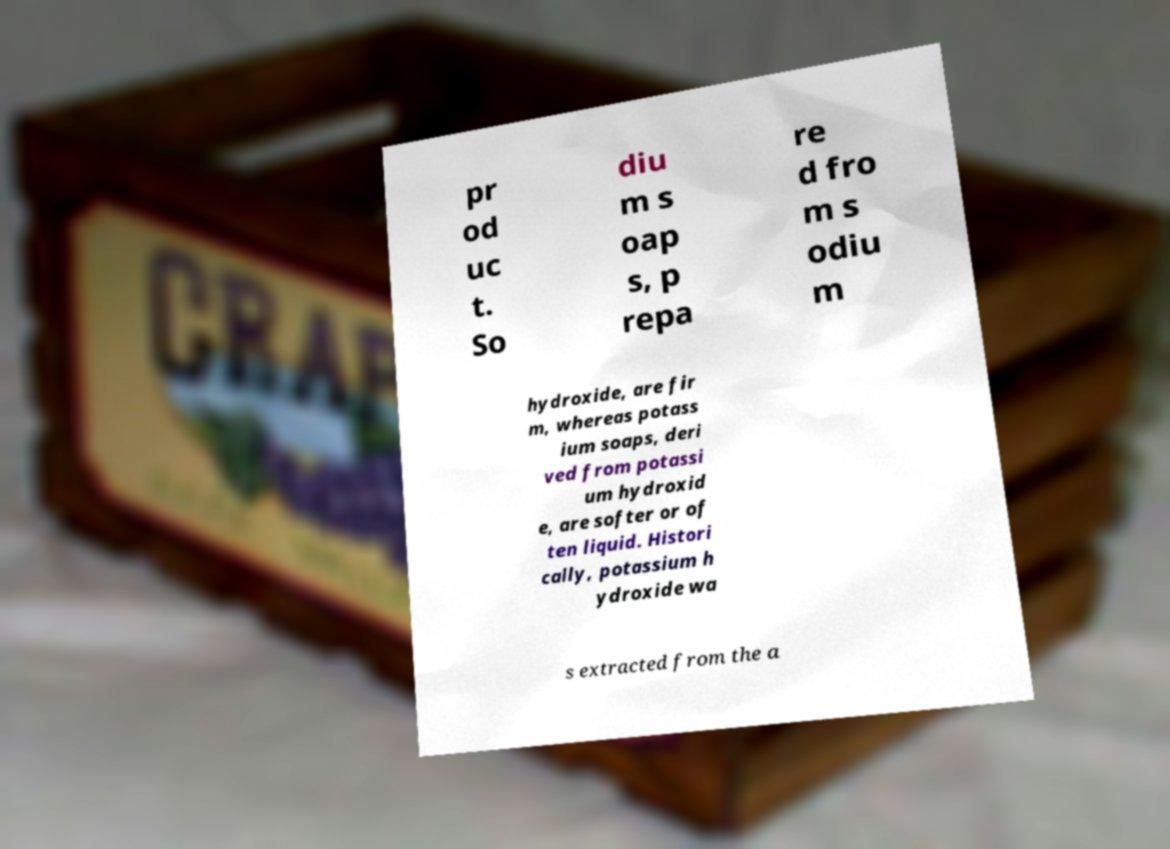Please read and relay the text visible in this image. What does it say? pr od uc t. So diu m s oap s, p repa re d fro m s odiu m hydroxide, are fir m, whereas potass ium soaps, deri ved from potassi um hydroxid e, are softer or of ten liquid. Histori cally, potassium h ydroxide wa s extracted from the a 